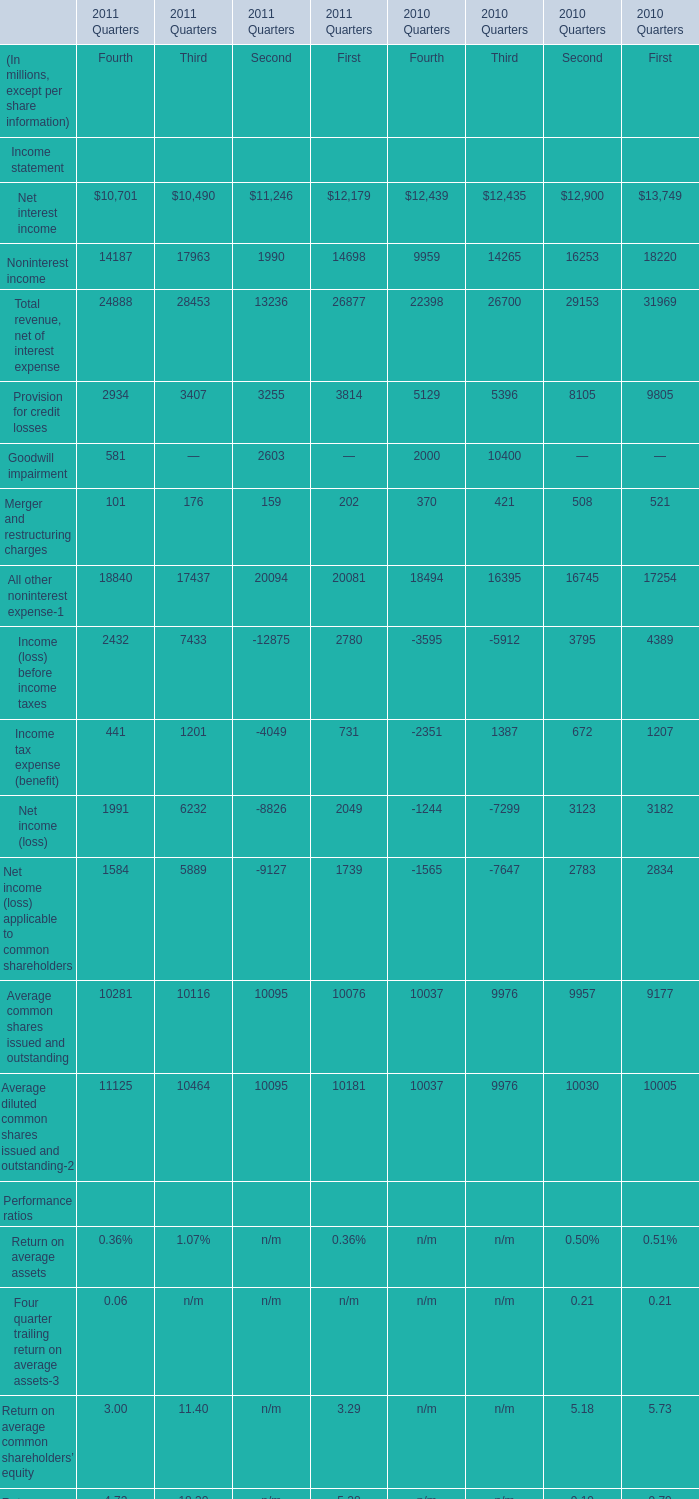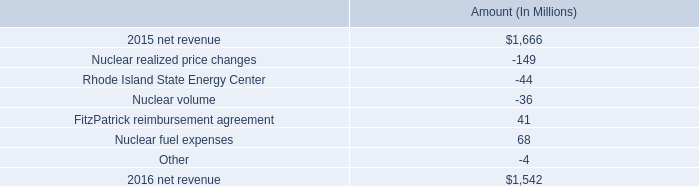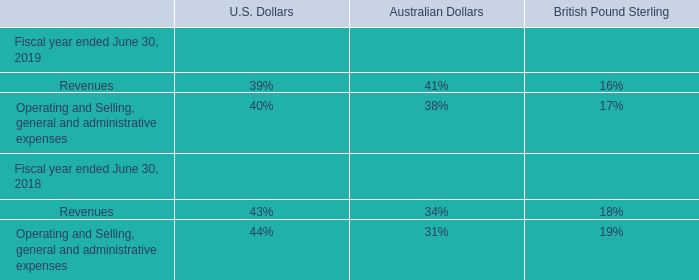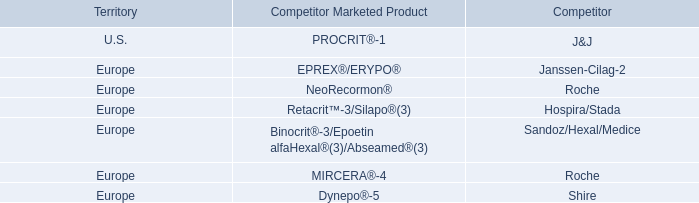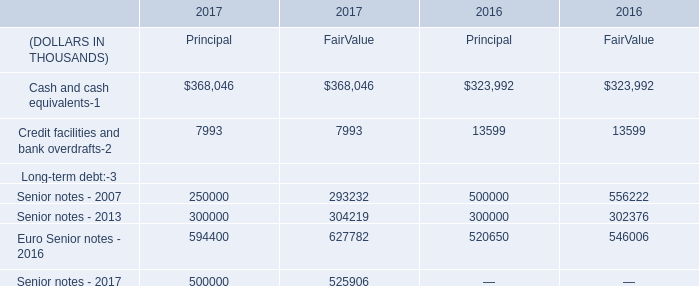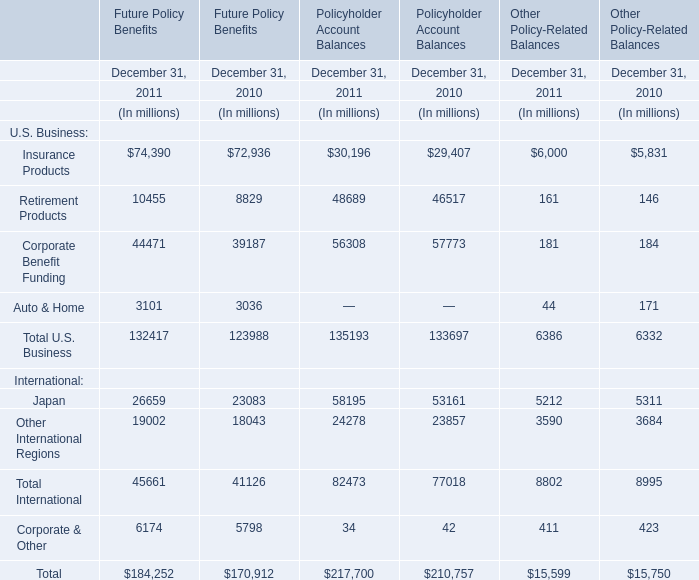What is the sum of Insurance Products, Retirement Products and Corporate Benefit Funding in 2011for Future Policy Benefits ? (in million) 
Computations: ((74390 + 10455) + 44471)
Answer: 129316.0. 